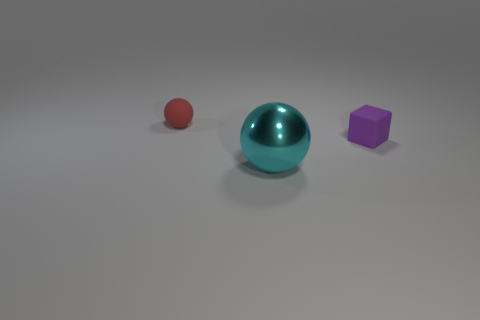How do the shadows cast by the objects inform us about the light source? The shadows in the image give us clues about the positions and intensity of the light source. Each object casts a shadow on the surface, indicating that the light source is above them, slightly to their left. The shadows are soft and diffused, suggesting that the light might be ambient or coming from a large source rather than being point-like. This soft lighting results in gentle shadow edges and indicates that the environment has even, indirect illumination. 